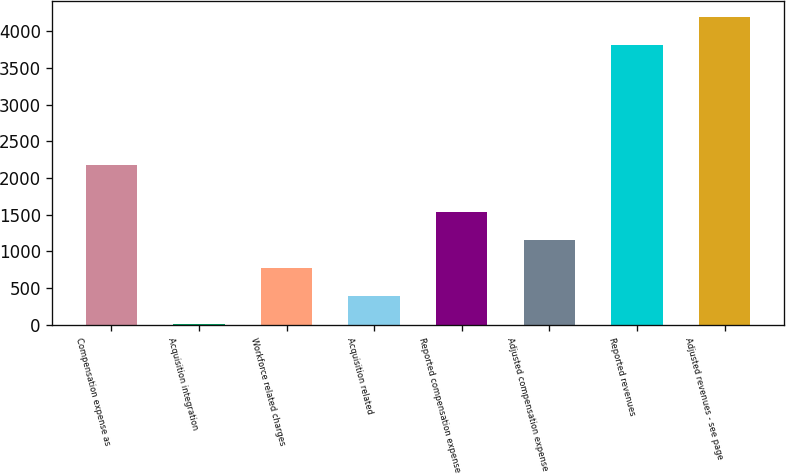<chart> <loc_0><loc_0><loc_500><loc_500><bar_chart><fcel>Compensation expense as<fcel>Acquisition integration<fcel>Workforce related charges<fcel>Acquisition related<fcel>Reported compensation expense<fcel>Adjusted compensation expense<fcel>Reported revenues<fcel>Adjusted revenues - see page<nl><fcel>2182.9<fcel>7.6<fcel>771.02<fcel>389.31<fcel>1534.44<fcel>1152.73<fcel>3815.1<fcel>4196.81<nl></chart> 